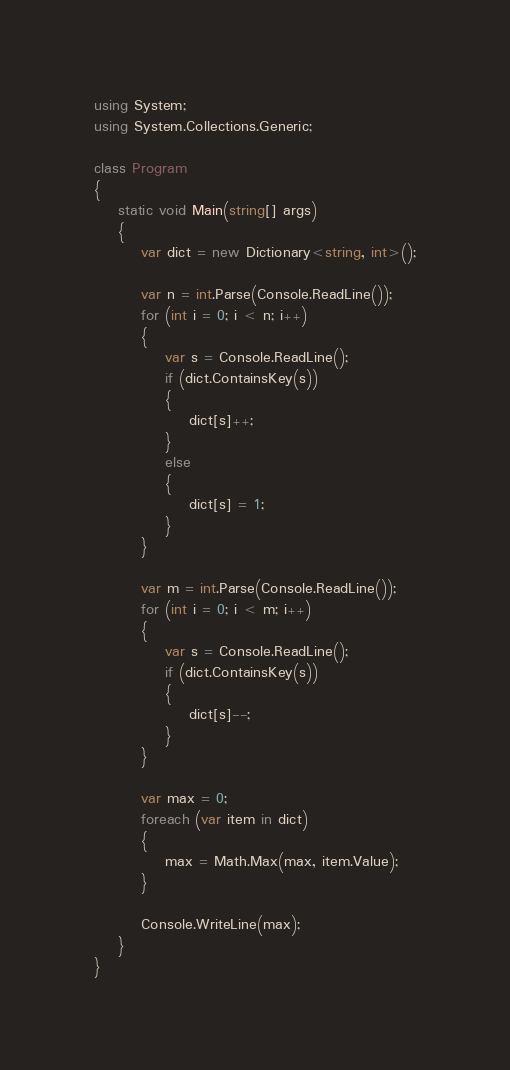Convert code to text. <code><loc_0><loc_0><loc_500><loc_500><_C#_>using System;
using System.Collections.Generic;

class Program
{
    static void Main(string[] args)
    {
        var dict = new Dictionary<string, int>();

        var n = int.Parse(Console.ReadLine());
        for (int i = 0; i < n; i++)
        {
            var s = Console.ReadLine();
            if (dict.ContainsKey(s))
            {
                dict[s]++;
            }
            else
            {
                dict[s] = 1;
            }
        }

        var m = int.Parse(Console.ReadLine());
        for (int i = 0; i < m; i++)
        {
            var s = Console.ReadLine();
            if (dict.ContainsKey(s))
            {
                dict[s]--;
            }
        }

        var max = 0;
        foreach (var item in dict)
        {
            max = Math.Max(max, item.Value);
        }

        Console.WriteLine(max);
    }
}
</code> 